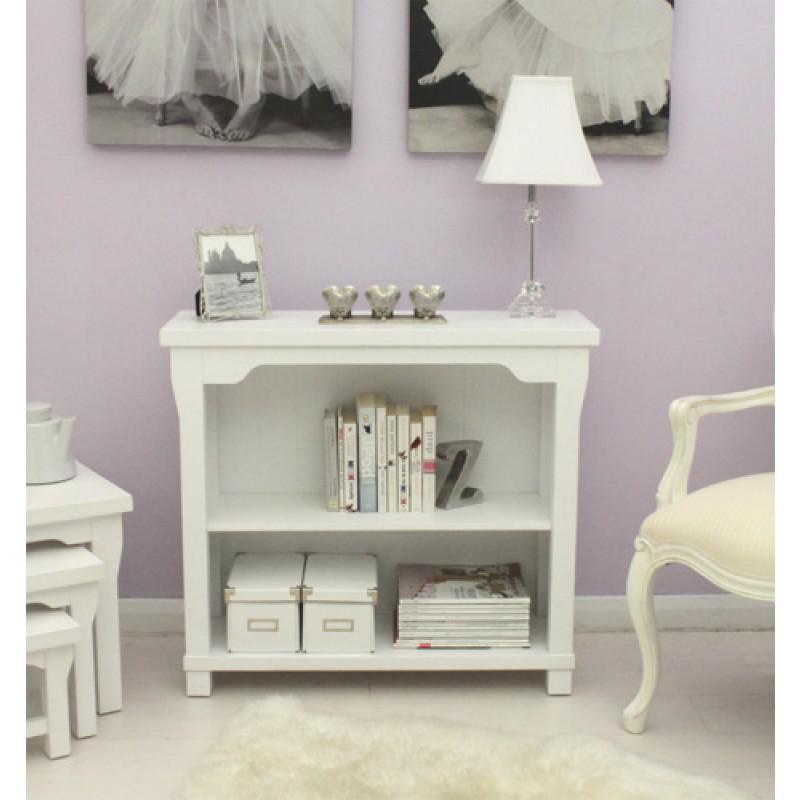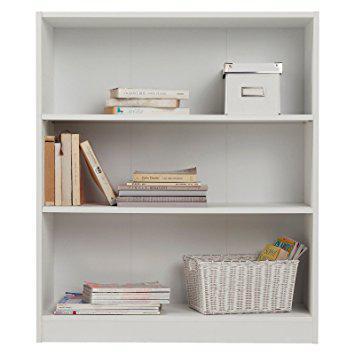The first image is the image on the left, the second image is the image on the right. Given the left and right images, does the statement "One of the bookshelves is not white." hold true? Answer yes or no. No. The first image is the image on the left, the second image is the image on the right. Examine the images to the left and right. Is the description "All shelf units shown are white, and all shelf units contain some books on some shelves." accurate? Answer yes or no. Yes. 